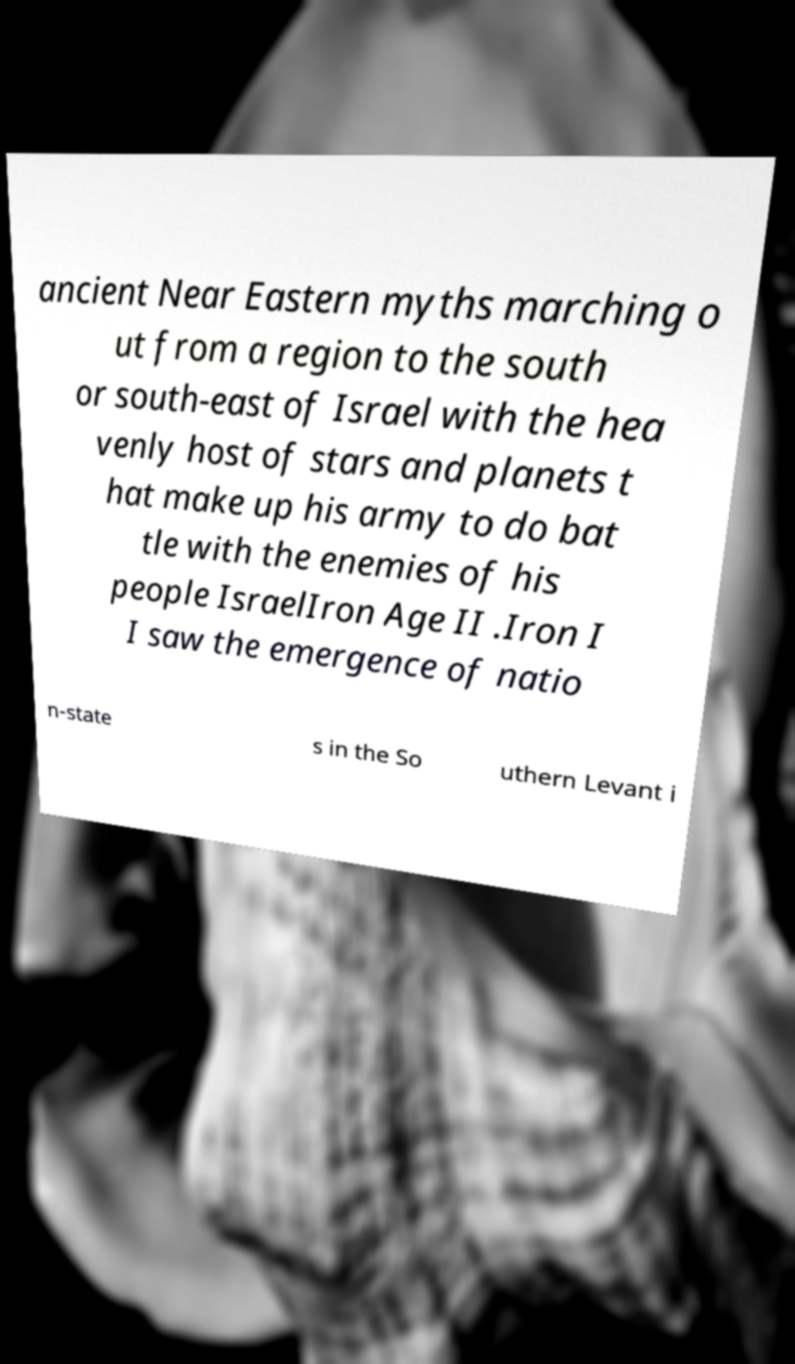There's text embedded in this image that I need extracted. Can you transcribe it verbatim? ancient Near Eastern myths marching o ut from a region to the south or south-east of Israel with the hea venly host of stars and planets t hat make up his army to do bat tle with the enemies of his people IsraelIron Age II .Iron I I saw the emergence of natio n-state s in the So uthern Levant i 